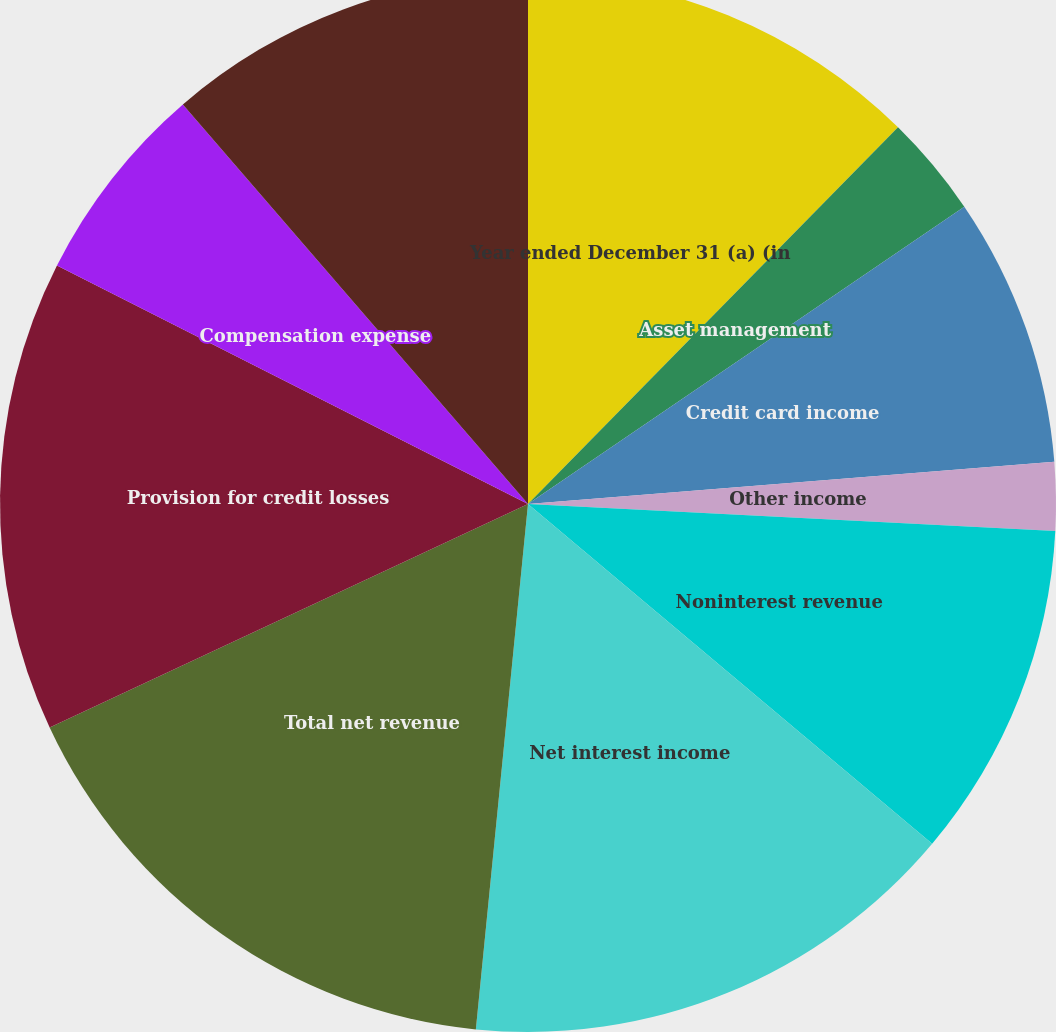<chart> <loc_0><loc_0><loc_500><loc_500><pie_chart><fcel>Year ended December 31 (a) (in<fcel>Asset management<fcel>Credit card income<fcel>Other income<fcel>Noninterest revenue<fcel>Net interest income<fcel>Total net revenue<fcel>Provision for credit losses<fcel>Compensation expense<fcel>Noncompensation expense<nl><fcel>12.36%<fcel>3.12%<fcel>8.25%<fcel>2.09%<fcel>10.31%<fcel>15.45%<fcel>16.47%<fcel>14.42%<fcel>6.2%<fcel>11.34%<nl></chart> 